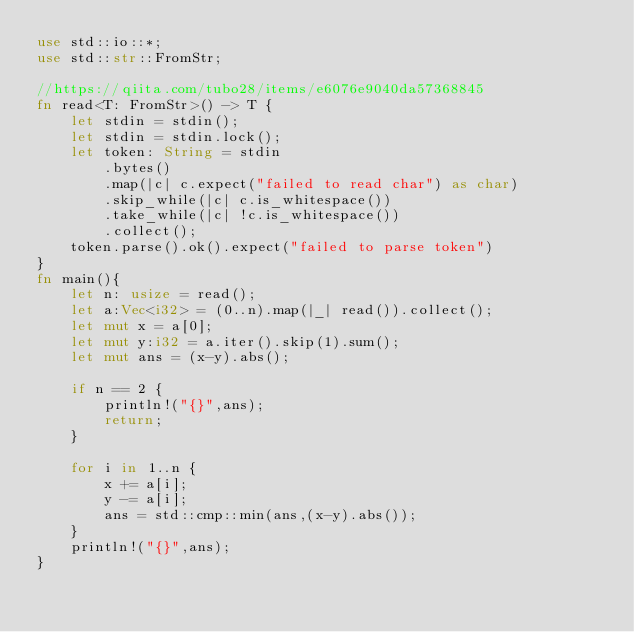Convert code to text. <code><loc_0><loc_0><loc_500><loc_500><_Rust_>use std::io::*;
use std::str::FromStr;

//https://qiita.com/tubo28/items/e6076e9040da57368845
fn read<T: FromStr>() -> T {
    let stdin = stdin();
    let stdin = stdin.lock();
    let token: String = stdin
        .bytes()
        .map(|c| c.expect("failed to read char") as char)
        .skip_while(|c| c.is_whitespace())
        .take_while(|c| !c.is_whitespace())
        .collect();
    token.parse().ok().expect("failed to parse token")
}
fn main(){
    let n: usize = read();
    let a:Vec<i32> = (0..n).map(|_| read()).collect();
    let mut x = a[0];
    let mut y:i32 = a.iter().skip(1).sum();
    let mut ans = (x-y).abs(); 

    if n == 2 {
        println!("{}",ans);
        return;
    }

    for i in 1..n {
        x += a[i];
        y -= a[i];
        ans = std::cmp::min(ans,(x-y).abs());
    }
    println!("{}",ans);
}
</code> 